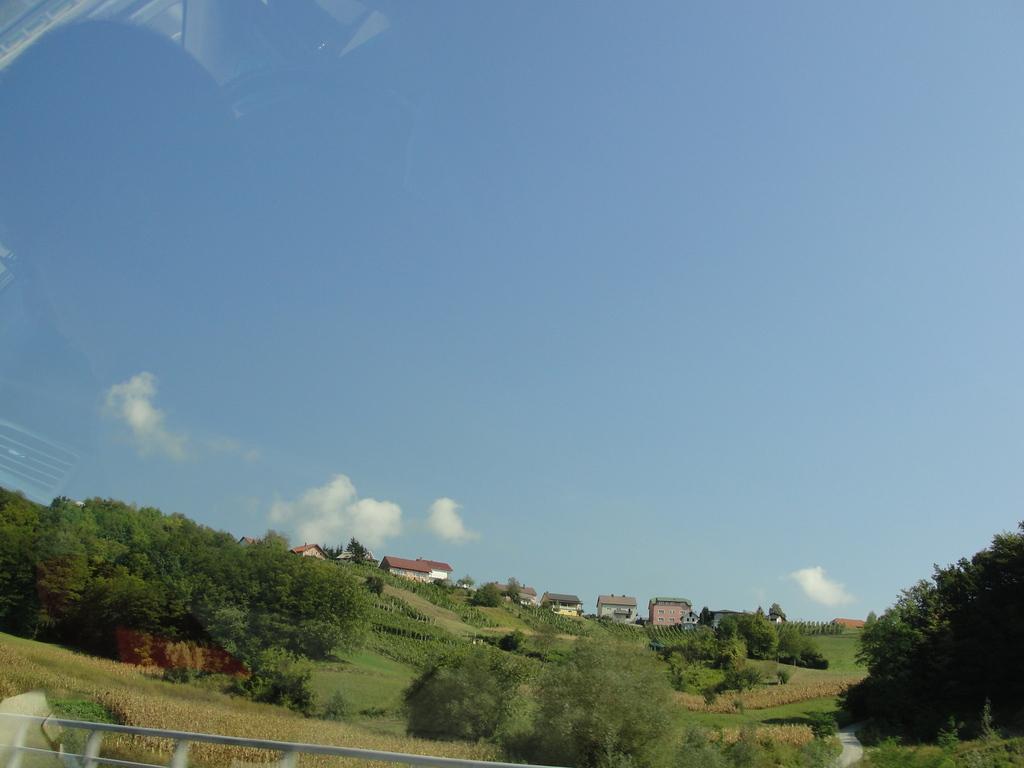Please provide a concise description of this image. In this picture we can see the grass, fence, trees, buildings and in the background we can see the sky with clouds. 